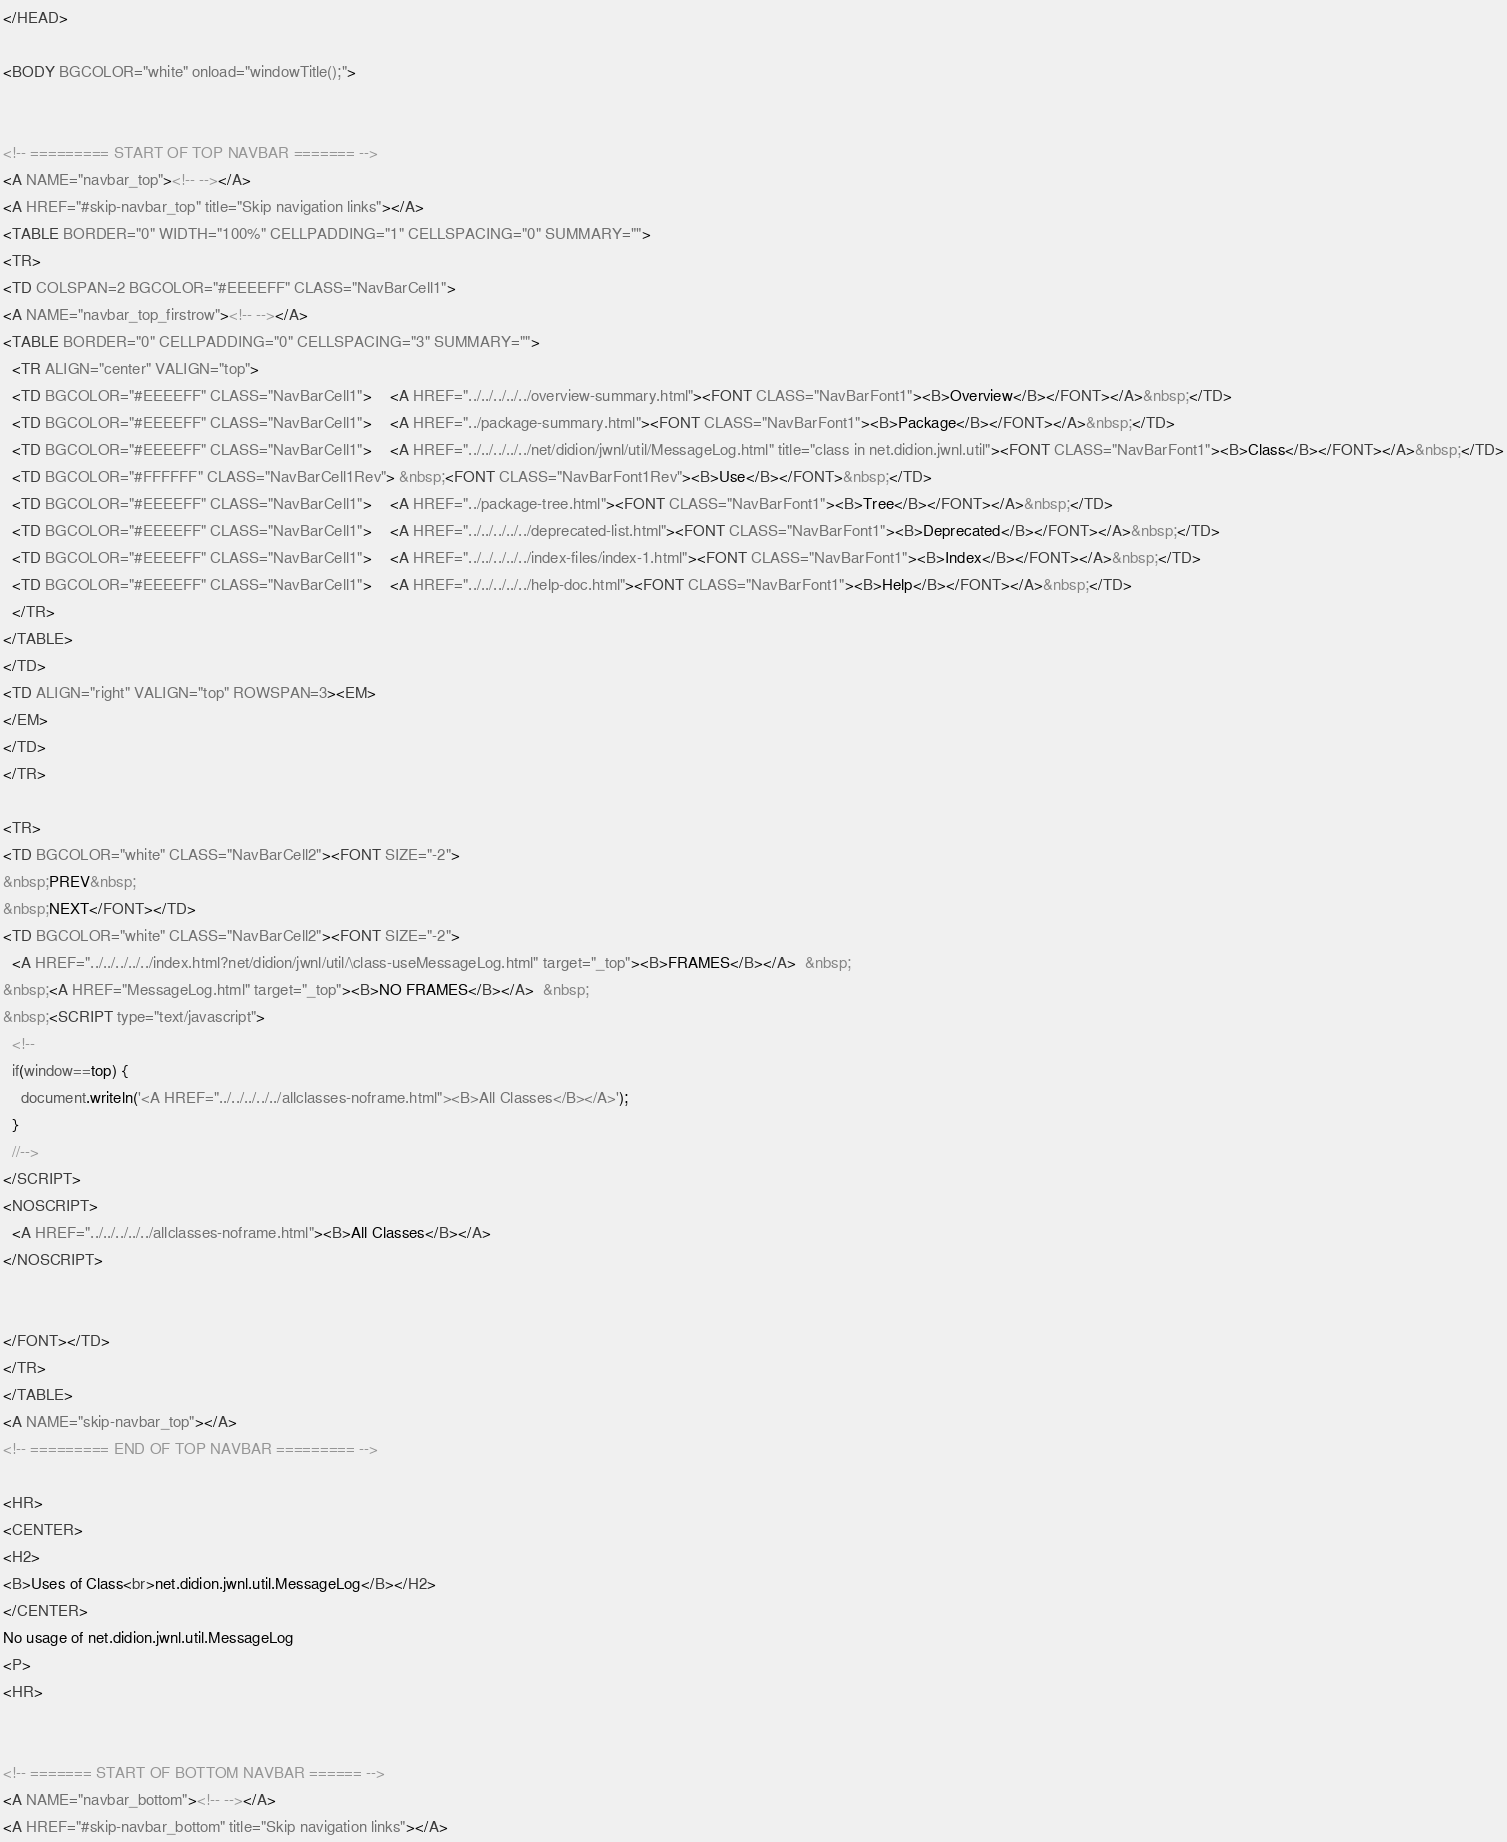<code> <loc_0><loc_0><loc_500><loc_500><_HTML_>
</HEAD>

<BODY BGCOLOR="white" onload="windowTitle();">


<!-- ========= START OF TOP NAVBAR ======= -->
<A NAME="navbar_top"><!-- --></A>
<A HREF="#skip-navbar_top" title="Skip navigation links"></A>
<TABLE BORDER="0" WIDTH="100%" CELLPADDING="1" CELLSPACING="0" SUMMARY="">
<TR>
<TD COLSPAN=2 BGCOLOR="#EEEEFF" CLASS="NavBarCell1">
<A NAME="navbar_top_firstrow"><!-- --></A>
<TABLE BORDER="0" CELLPADDING="0" CELLSPACING="3" SUMMARY="">
  <TR ALIGN="center" VALIGN="top">
  <TD BGCOLOR="#EEEEFF" CLASS="NavBarCell1">    <A HREF="../../../../../overview-summary.html"><FONT CLASS="NavBarFont1"><B>Overview</B></FONT></A>&nbsp;</TD>
  <TD BGCOLOR="#EEEEFF" CLASS="NavBarCell1">    <A HREF="../package-summary.html"><FONT CLASS="NavBarFont1"><B>Package</B></FONT></A>&nbsp;</TD>
  <TD BGCOLOR="#EEEEFF" CLASS="NavBarCell1">    <A HREF="../../../../../net/didion/jwnl/util/MessageLog.html" title="class in net.didion.jwnl.util"><FONT CLASS="NavBarFont1"><B>Class</B></FONT></A>&nbsp;</TD>
  <TD BGCOLOR="#FFFFFF" CLASS="NavBarCell1Rev"> &nbsp;<FONT CLASS="NavBarFont1Rev"><B>Use</B></FONT>&nbsp;</TD>
  <TD BGCOLOR="#EEEEFF" CLASS="NavBarCell1">    <A HREF="../package-tree.html"><FONT CLASS="NavBarFont1"><B>Tree</B></FONT></A>&nbsp;</TD>
  <TD BGCOLOR="#EEEEFF" CLASS="NavBarCell1">    <A HREF="../../../../../deprecated-list.html"><FONT CLASS="NavBarFont1"><B>Deprecated</B></FONT></A>&nbsp;</TD>
  <TD BGCOLOR="#EEEEFF" CLASS="NavBarCell1">    <A HREF="../../../../../index-files/index-1.html"><FONT CLASS="NavBarFont1"><B>Index</B></FONT></A>&nbsp;</TD>
  <TD BGCOLOR="#EEEEFF" CLASS="NavBarCell1">    <A HREF="../../../../../help-doc.html"><FONT CLASS="NavBarFont1"><B>Help</B></FONT></A>&nbsp;</TD>
  </TR>
</TABLE>
</TD>
<TD ALIGN="right" VALIGN="top" ROWSPAN=3><EM>
</EM>
</TD>
</TR>

<TR>
<TD BGCOLOR="white" CLASS="NavBarCell2"><FONT SIZE="-2">
&nbsp;PREV&nbsp;
&nbsp;NEXT</FONT></TD>
<TD BGCOLOR="white" CLASS="NavBarCell2"><FONT SIZE="-2">
  <A HREF="../../../../../index.html?net/didion/jwnl/util/\class-useMessageLog.html" target="_top"><B>FRAMES</B></A>  &nbsp;
&nbsp;<A HREF="MessageLog.html" target="_top"><B>NO FRAMES</B></A>  &nbsp;
&nbsp;<SCRIPT type="text/javascript">
  <!--
  if(window==top) {
    document.writeln('<A HREF="../../../../../allclasses-noframe.html"><B>All Classes</B></A>');
  }
  //-->
</SCRIPT>
<NOSCRIPT>
  <A HREF="../../../../../allclasses-noframe.html"><B>All Classes</B></A>
</NOSCRIPT>


</FONT></TD>
</TR>
</TABLE>
<A NAME="skip-navbar_top"></A>
<!-- ========= END OF TOP NAVBAR ========= -->

<HR>
<CENTER>
<H2>
<B>Uses of Class<br>net.didion.jwnl.util.MessageLog</B></H2>
</CENTER>
No usage of net.didion.jwnl.util.MessageLog
<P>
<HR>


<!-- ======= START OF BOTTOM NAVBAR ====== -->
<A NAME="navbar_bottom"><!-- --></A>
<A HREF="#skip-navbar_bottom" title="Skip navigation links"></A></code> 